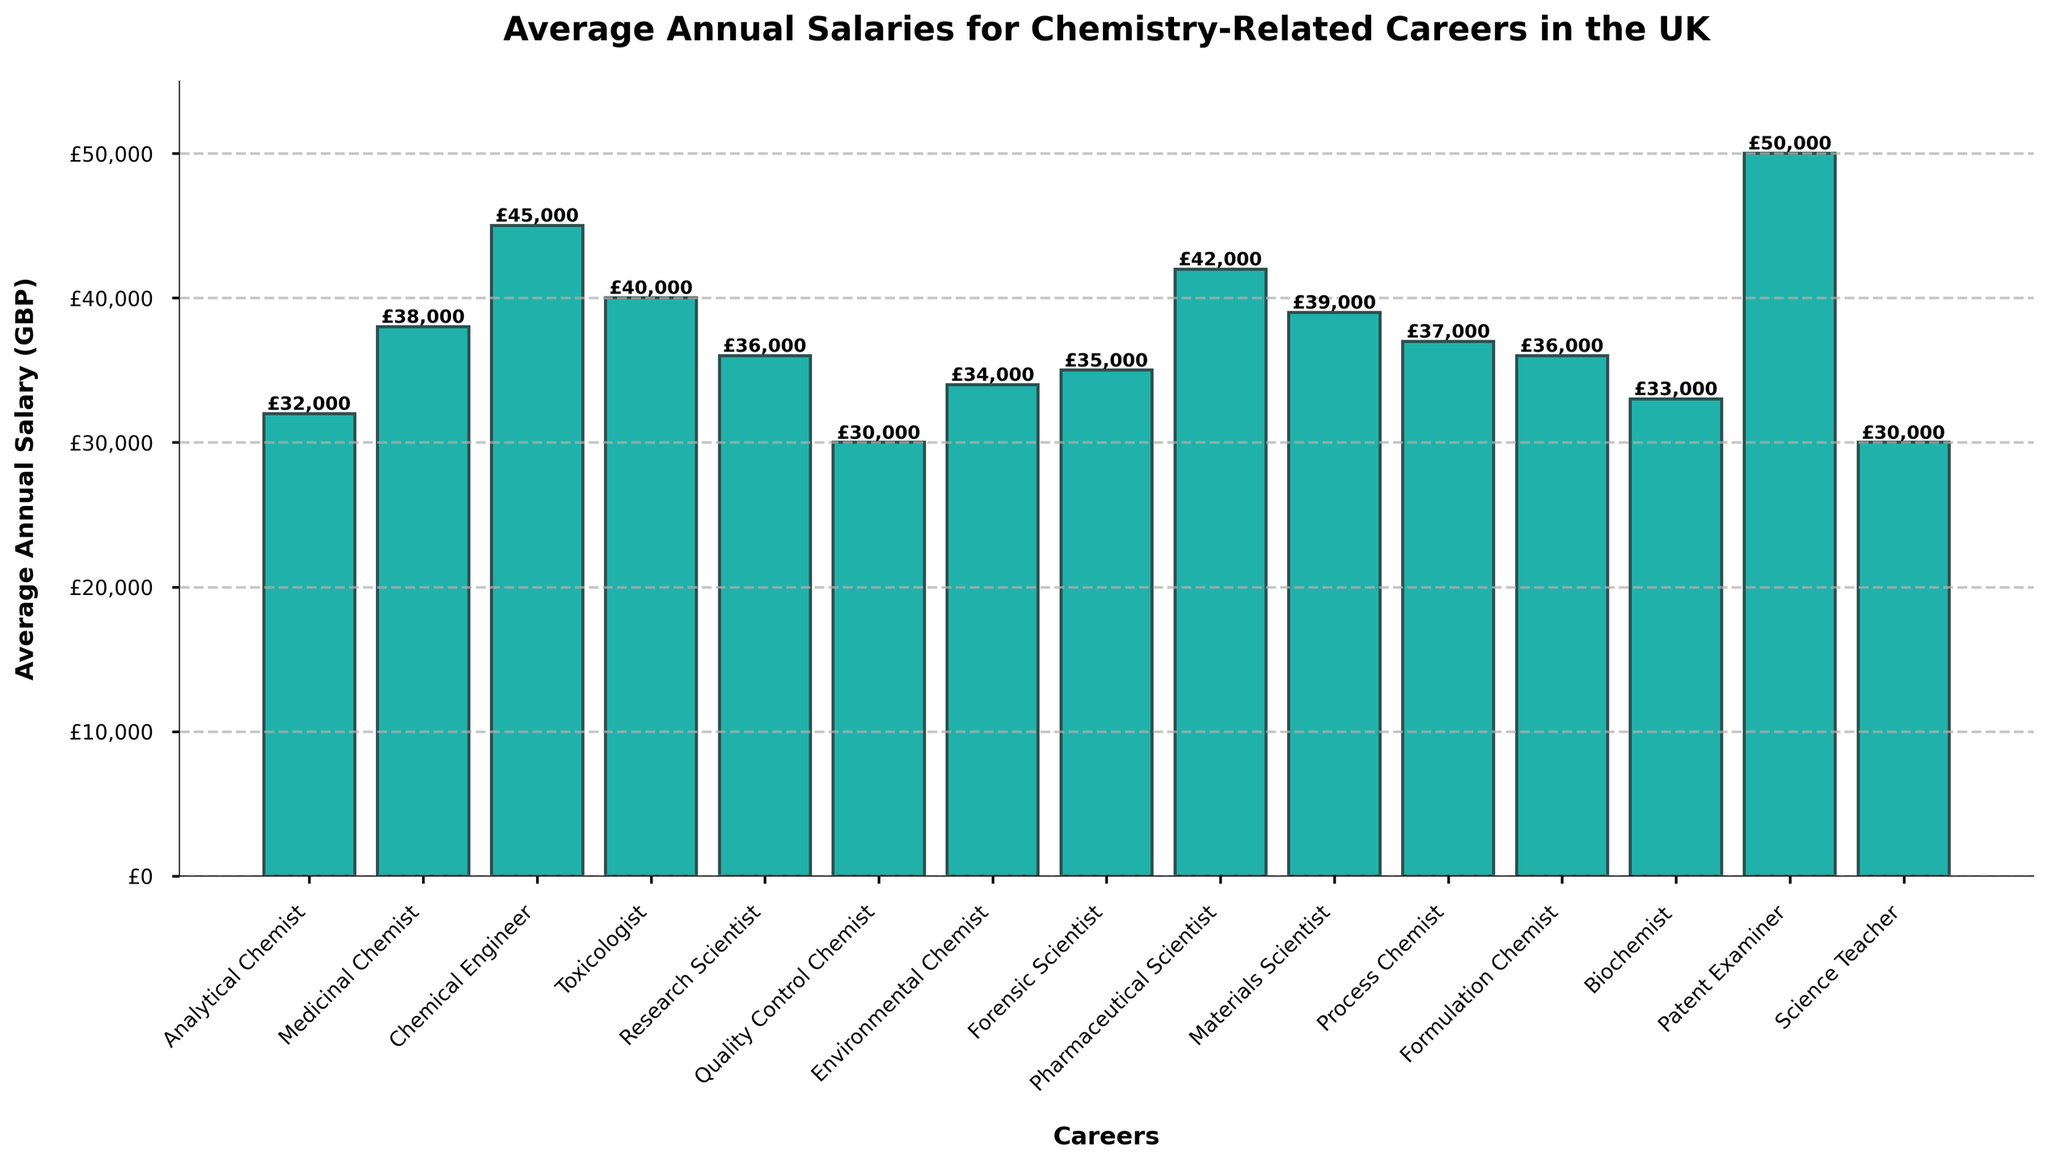Which career has the highest average annual salary? The bars in the bar chart represent the average annual salaries for different careers. The tallest bar corresponds to the highest salary, which is for the 'Patent Examiner'.
Answer: Patent Examiner What is the difference in average annual salary between a Chemical Engineer and a Science Teacher? Find the height of the bars for 'Chemical Engineer' and 'Science Teacher'. The average salary for a Chemical Engineer is £45,000 and for a Science Teacher is £30,000. Subtract £30,000 from £45,000.
Answer: £15,000 Which career has a lower average annual salary: Biochemist or Forensic Scientist? Compare the heights of the bars for 'Biochemist' (£33,000) and 'Forensic Scientist' (£35,000). The bar for 'Biochemist' is shorter.
Answer: Biochemist What is the sum of the average salaries for a Medicinal Chemist, a Toxicologist, and a Formulation Chemist? Add the average annual salaries for 'Medicinal Chemist' (£38,000), 'Toxicologist' (£40,000), and 'Formulation Chemist' (£36,000). The sum is £38,000 + £40,000 + £36,000.
Answer: £114,000 Which career earns more on average, an Environmental Chemist or a Research Scientist? Compare the bars for 'Environmental Chemist' (£34,000) and 'Research Scientist' (£36,000). The bar for 'Research Scientist' is taller.
Answer: Research Scientist What is the average salary of the careers that earn £36,000 annually? Identify the careers with bars at the £36,000 mark: 'Research Scientist' and 'Formulation Chemist'. The average of £36,000 and £36,000 is (£36,000 + £36,000) / 2.
Answer: £36,000 How much more does a Pharmaceutical Scientist make compared to an Analytical Chemist? Find the bar heights for 'Pharmaceutical Scientist' (£42,000) and 'Analytical Chemist' (£32,000). Subtract £32,000 from £42,000.
Answer: £10,000 What's the average annual salary of the careers represented in the bar chart? Sum the average salaries of all the careers and divide by the number of careers (15). The sum is £32,000 + £38,000 + £45,000 + £40,000 + £36,000 + £30,000 + £34,000 + £35,000 + £42,000 + £39,000 + £37,000 + £36,000 + £33,000 + £50,000 + £30,000 = £557,000. Dividing by 15 gives £557,000 / 15.
Answer: £37,133 